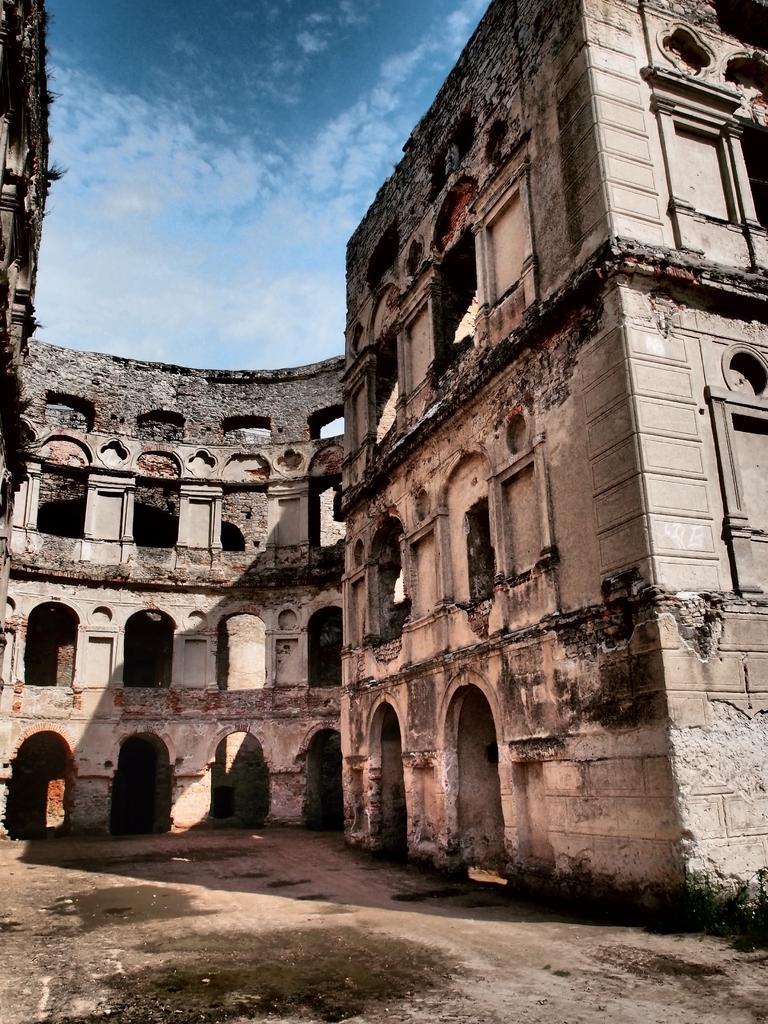Please provide a concise description of this image. In this picture I can see a building and cloudy sky. 